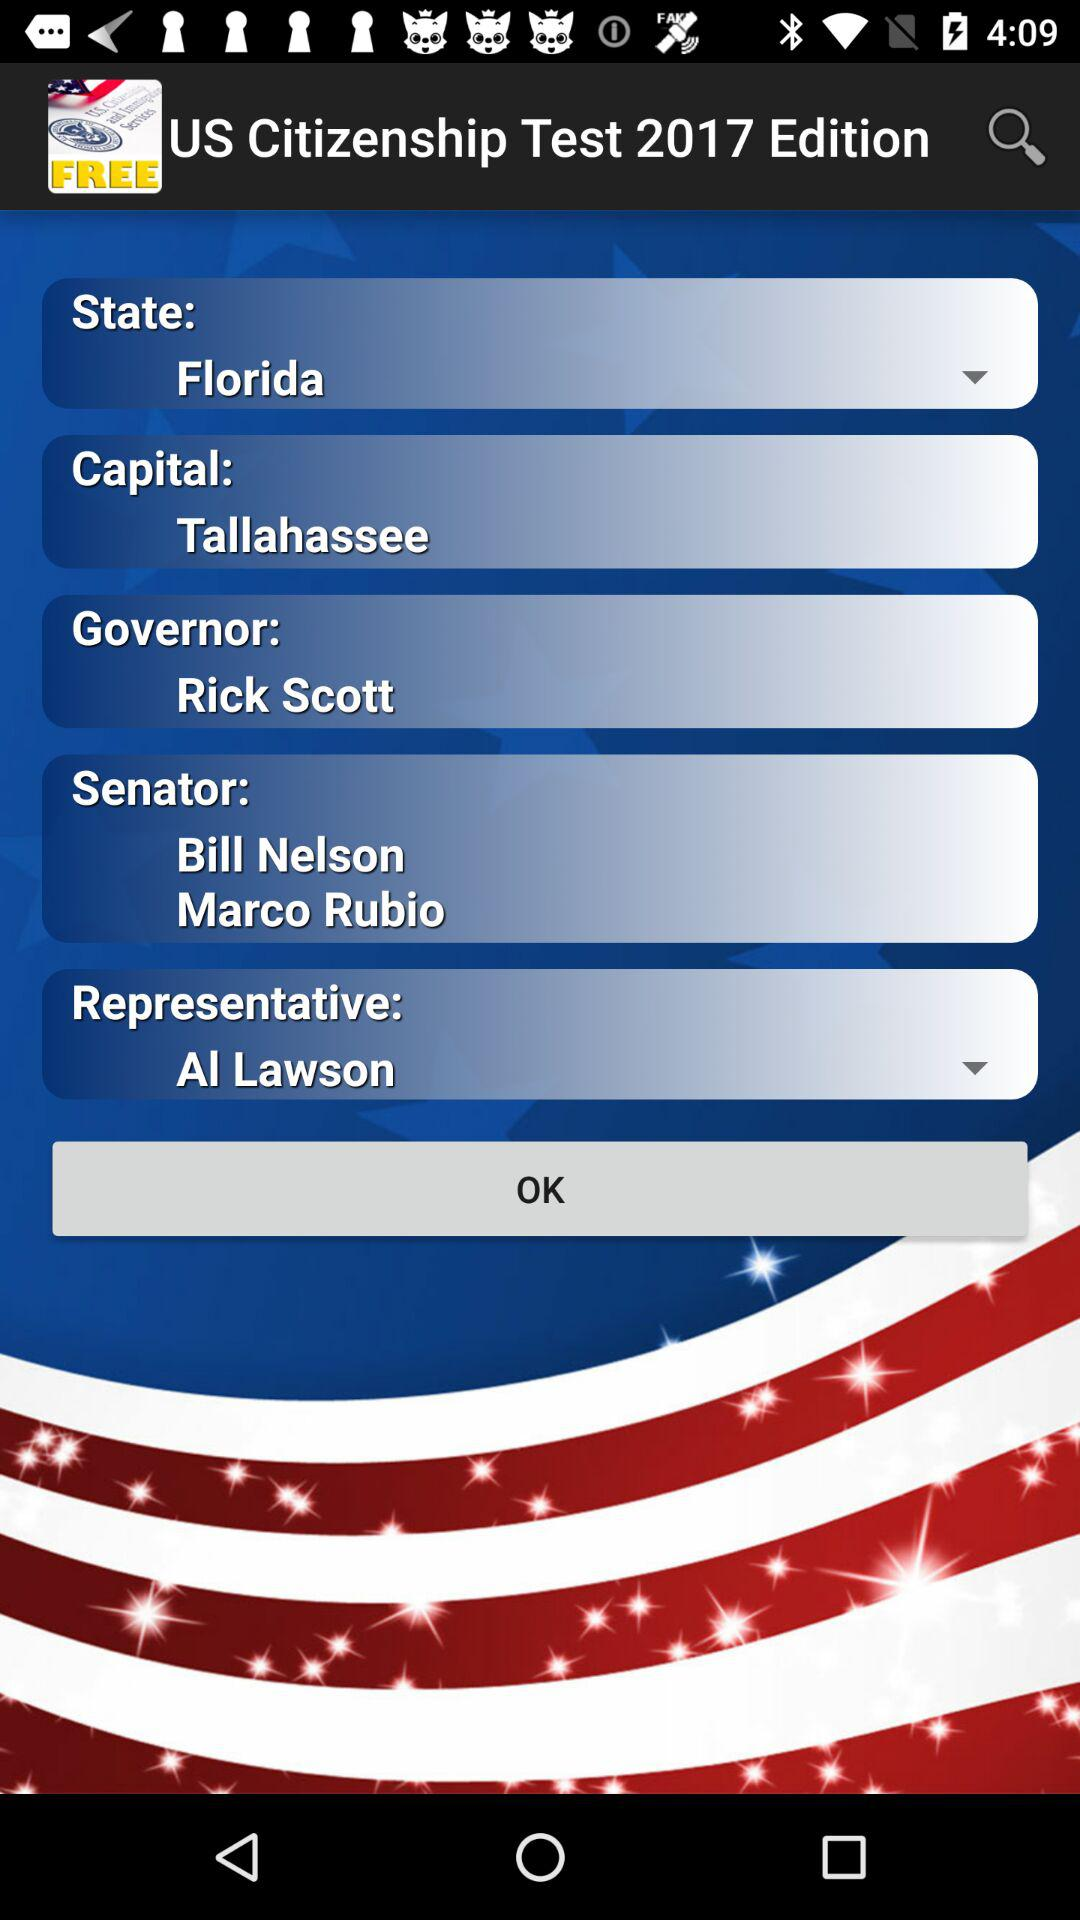Who is the governor? The governor is Rick Scott. 